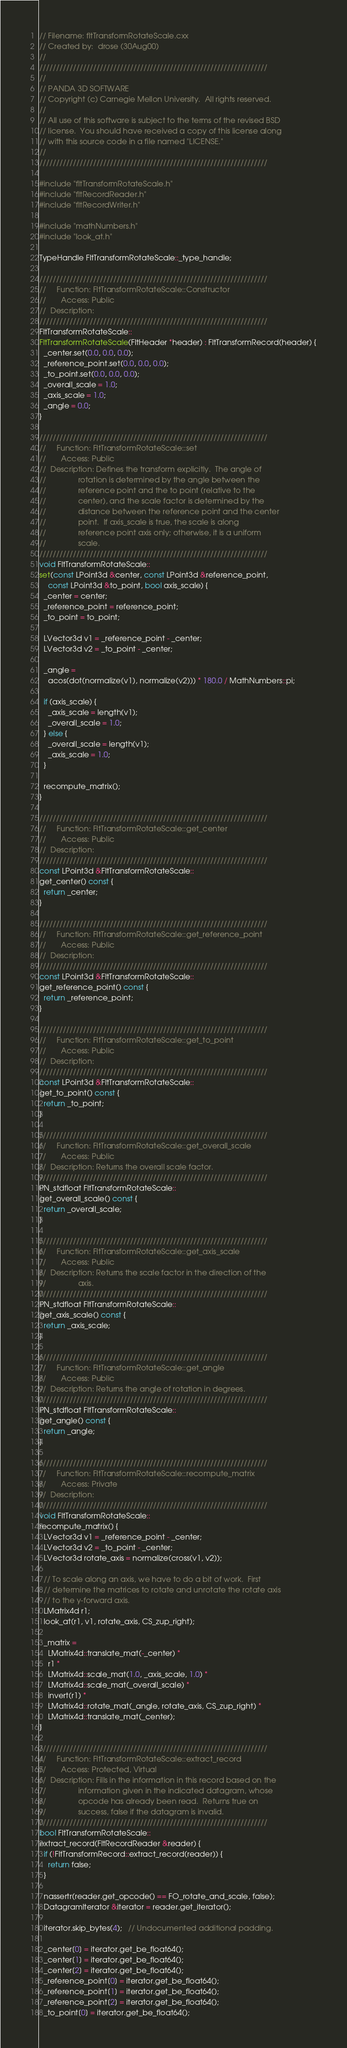<code> <loc_0><loc_0><loc_500><loc_500><_C++_>// Filename: fltTransformRotateScale.cxx
// Created by:  drose (30Aug00)
//
////////////////////////////////////////////////////////////////////
//
// PANDA 3D SOFTWARE
// Copyright (c) Carnegie Mellon University.  All rights reserved.
//
// All use of this software is subject to the terms of the revised BSD
// license.  You should have received a copy of this license along
// with this source code in a file named "LICENSE."
//
////////////////////////////////////////////////////////////////////

#include "fltTransformRotateScale.h"
#include "fltRecordReader.h"
#include "fltRecordWriter.h"

#include "mathNumbers.h"
#include "look_at.h"

TypeHandle FltTransformRotateScale::_type_handle;

////////////////////////////////////////////////////////////////////
//     Function: FltTransformRotateScale::Constructor
//       Access: Public
//  Description:
////////////////////////////////////////////////////////////////////
FltTransformRotateScale::
FltTransformRotateScale(FltHeader *header) : FltTransformRecord(header) {
  _center.set(0.0, 0.0, 0.0);
  _reference_point.set(0.0, 0.0, 0.0);
  _to_point.set(0.0, 0.0, 0.0);
  _overall_scale = 1.0;
  _axis_scale = 1.0;
  _angle = 0.0;
}

////////////////////////////////////////////////////////////////////
//     Function: FltTransformRotateScale::set
//       Access: Public
//  Description: Defines the transform explicitly.  The angle of
//               rotation is determined by the angle between the
//               reference point and the to point (relative to the
//               center), and the scale factor is determined by the
//               distance between the reference point and the center
//               point.  If axis_scale is true, the scale is along
//               reference point axis only; otherwise, it is a uniform
//               scale.
////////////////////////////////////////////////////////////////////
void FltTransformRotateScale::
set(const LPoint3d &center, const LPoint3d &reference_point,
    const LPoint3d &to_point, bool axis_scale) {
  _center = center;
  _reference_point = reference_point;
  _to_point = to_point;

  LVector3d v1 = _reference_point - _center;
  LVector3d v2 = _to_point - _center;

  _angle =
    acos(dot(normalize(v1), normalize(v2))) * 180.0 / MathNumbers::pi;

  if (axis_scale) {
    _axis_scale = length(v1);
    _overall_scale = 1.0;
  } else {
    _overall_scale = length(v1);
    _axis_scale = 1.0;
  }

  recompute_matrix();
}

////////////////////////////////////////////////////////////////////
//     Function: FltTransformRotateScale::get_center
//       Access: Public
//  Description:
////////////////////////////////////////////////////////////////////
const LPoint3d &FltTransformRotateScale::
get_center() const {
  return _center;
}

////////////////////////////////////////////////////////////////////
//     Function: FltTransformRotateScale::get_reference_point
//       Access: Public
//  Description:
////////////////////////////////////////////////////////////////////
const LPoint3d &FltTransformRotateScale::
get_reference_point() const {
  return _reference_point;
}

////////////////////////////////////////////////////////////////////
//     Function: FltTransformRotateScale::get_to_point
//       Access: Public
//  Description:
////////////////////////////////////////////////////////////////////
const LPoint3d &FltTransformRotateScale::
get_to_point() const {
  return _to_point;
}

////////////////////////////////////////////////////////////////////
//     Function: FltTransformRotateScale::get_overall_scale
//       Access: Public
//  Description: Returns the overall scale factor.
////////////////////////////////////////////////////////////////////
PN_stdfloat FltTransformRotateScale::
get_overall_scale() const {
  return _overall_scale;
}

////////////////////////////////////////////////////////////////////
//     Function: FltTransformRotateScale::get_axis_scale
//       Access: Public
//  Description: Returns the scale factor in the direction of the
//               axis.
////////////////////////////////////////////////////////////////////
PN_stdfloat FltTransformRotateScale::
get_axis_scale() const {
  return _axis_scale;
}

////////////////////////////////////////////////////////////////////
//     Function: FltTransformRotateScale::get_angle
//       Access: Public
//  Description: Returns the angle of rotation in degrees.
////////////////////////////////////////////////////////////////////
PN_stdfloat FltTransformRotateScale::
get_angle() const {
  return _angle;
}

////////////////////////////////////////////////////////////////////
//     Function: FltTransformRotateScale::recompute_matrix
//       Access: Private
//  Description:
////////////////////////////////////////////////////////////////////
void FltTransformRotateScale::
recompute_matrix() {
  LVector3d v1 = _reference_point - _center;
  LVector3d v2 = _to_point - _center;
  LVector3d rotate_axis = normalize(cross(v1, v2));

  // To scale along an axis, we have to do a bit of work.  First
  // determine the matrices to rotate and unrotate the rotate axis
  // to the y-forward axis.
  LMatrix4d r1;
  look_at(r1, v1, rotate_axis, CS_zup_right);

  _matrix =
    LMatrix4d::translate_mat(-_center) *
    r1 *
    LMatrix4d::scale_mat(1.0, _axis_scale, 1.0) *
    LMatrix4d::scale_mat(_overall_scale) *
    invert(r1) *
    LMatrix4d::rotate_mat(_angle, rotate_axis, CS_zup_right) *
    LMatrix4d::translate_mat(_center);
}

////////////////////////////////////////////////////////////////////
//     Function: FltTransformRotateScale::extract_record
//       Access: Protected, Virtual
//  Description: Fills in the information in this record based on the
//               information given in the indicated datagram, whose
//               opcode has already been read.  Returns true on
//               success, false if the datagram is invalid.
////////////////////////////////////////////////////////////////////
bool FltTransformRotateScale::
extract_record(FltRecordReader &reader) {
  if (!FltTransformRecord::extract_record(reader)) {
    return false;
  }

  nassertr(reader.get_opcode() == FO_rotate_and_scale, false);
  DatagramIterator &iterator = reader.get_iterator();

  iterator.skip_bytes(4);   // Undocumented additional padding.

  _center[0] = iterator.get_be_float64();
  _center[1] = iterator.get_be_float64();
  _center[2] = iterator.get_be_float64();
  _reference_point[0] = iterator.get_be_float64();
  _reference_point[1] = iterator.get_be_float64();
  _reference_point[2] = iterator.get_be_float64();
  _to_point[0] = iterator.get_be_float64();</code> 